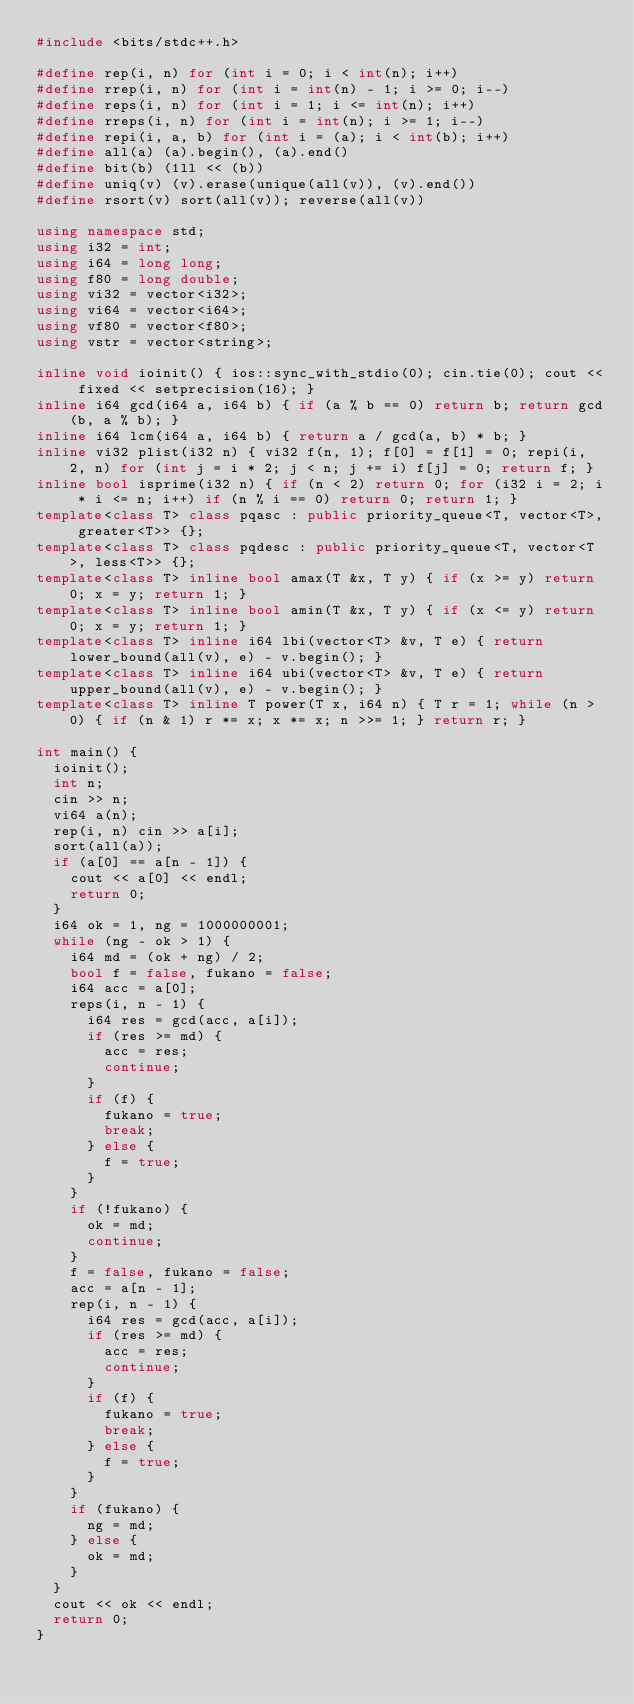<code> <loc_0><loc_0><loc_500><loc_500><_C++_>#include <bits/stdc++.h>

#define rep(i, n) for (int i = 0; i < int(n); i++)
#define rrep(i, n) for (int i = int(n) - 1; i >= 0; i--)
#define reps(i, n) for (int i = 1; i <= int(n); i++)
#define rreps(i, n) for (int i = int(n); i >= 1; i--)
#define repi(i, a, b) for (int i = (a); i < int(b); i++)
#define all(a) (a).begin(), (a).end()
#define bit(b) (1ll << (b))
#define uniq(v) (v).erase(unique(all(v)), (v).end())
#define rsort(v) sort(all(v)); reverse(all(v))

using namespace std;
using i32 = int;
using i64 = long long;
using f80 = long double;
using vi32 = vector<i32>;
using vi64 = vector<i64>;
using vf80 = vector<f80>;
using vstr = vector<string>;

inline void ioinit() { ios::sync_with_stdio(0); cin.tie(0); cout << fixed << setprecision(16); }
inline i64 gcd(i64 a, i64 b) { if (a % b == 0) return b; return gcd(b, a % b); }
inline i64 lcm(i64 a, i64 b) { return a / gcd(a, b) * b; }
inline vi32 plist(i32 n) { vi32 f(n, 1); f[0] = f[1] = 0; repi(i, 2, n) for (int j = i * 2; j < n; j += i) f[j] = 0; return f; }
inline bool isprime(i32 n) { if (n < 2) return 0; for (i32 i = 2; i * i <= n; i++) if (n % i == 0) return 0; return 1; }
template<class T> class pqasc : public priority_queue<T, vector<T>, greater<T>> {};
template<class T> class pqdesc : public priority_queue<T, vector<T>, less<T>> {};
template<class T> inline bool amax(T &x, T y) { if (x >= y) return 0; x = y; return 1; }
template<class T> inline bool amin(T &x, T y) { if (x <= y) return 0; x = y; return 1; }
template<class T> inline i64 lbi(vector<T> &v, T e) { return lower_bound(all(v), e) - v.begin(); }
template<class T> inline i64 ubi(vector<T> &v, T e) { return upper_bound(all(v), e) - v.begin(); }
template<class T> inline T power(T x, i64 n) { T r = 1; while (n > 0) { if (n & 1) r *= x; x *= x; n >>= 1; } return r; }

int main() {
  ioinit();
  int n;
  cin >> n;
  vi64 a(n);
  rep(i, n) cin >> a[i];
  sort(all(a));
  if (a[0] == a[n - 1]) {
    cout << a[0] << endl;
    return 0;
  }
  i64 ok = 1, ng = 1000000001;
  while (ng - ok > 1) {
    i64 md = (ok + ng) / 2;
    bool f = false, fukano = false;
    i64 acc = a[0];
    reps(i, n - 1) {
      i64 res = gcd(acc, a[i]);
      if (res >= md) {
        acc = res;
        continue;
      }
      if (f) {
        fukano = true;
        break;
      } else {
        f = true;
      }
    }
    if (!fukano) {
      ok = md;
      continue;
    }
    f = false, fukano = false;
    acc = a[n - 1];
    rep(i, n - 1) {
      i64 res = gcd(acc, a[i]);
      if (res >= md) {
        acc = res;
        continue;
      }
      if (f) {
        fukano = true;
        break;
      } else {
        f = true;
      }
    }
    if (fukano) {
      ng = md;
    } else {
      ok = md;
    }
  }
  cout << ok << endl;
  return 0;
}
</code> 